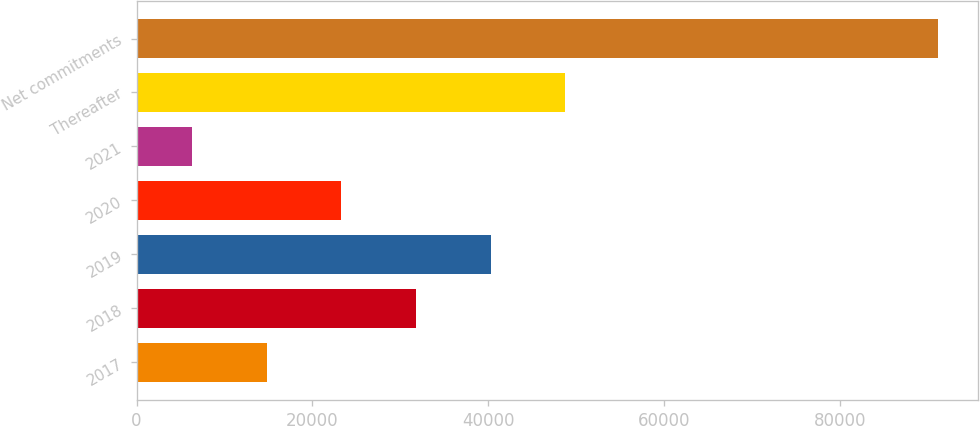Convert chart to OTSL. <chart><loc_0><loc_0><loc_500><loc_500><bar_chart><fcel>2017<fcel>2018<fcel>2019<fcel>2020<fcel>2021<fcel>Thereafter<fcel>Net commitments<nl><fcel>14818<fcel>31790.2<fcel>40276.3<fcel>23304.1<fcel>6307<fcel>48762.4<fcel>91168<nl></chart> 